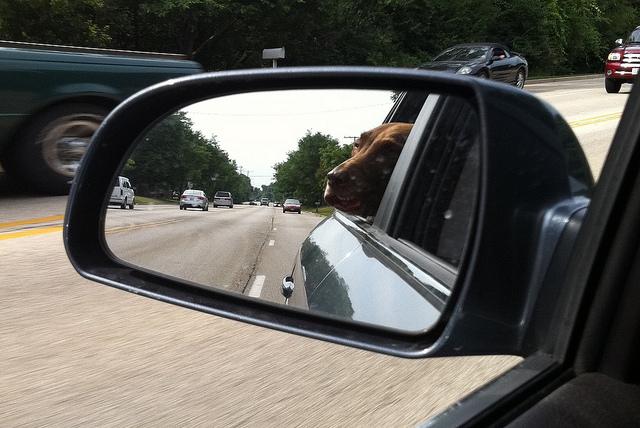Is the dog looking at his image?
Give a very brief answer. No. What do the words on the mirror say?
Write a very short answer. No words. Is the mirror on the driver's side?
Write a very short answer. Yes. Whose head do you see in this picture?
Be succinct. Dog. What is the breed of dog in the vehicle?
Keep it brief. Lab. Is it safe to merge left?
Answer briefly. Yes. Is there more than 1 car?
Answer briefly. Yes. 